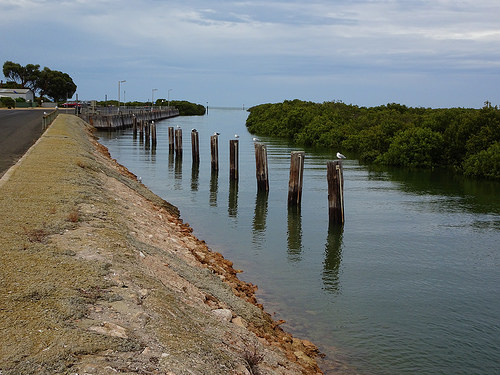<image>
Is there a seagull next to the water? Yes. The seagull is positioned adjacent to the water, located nearby in the same general area. 